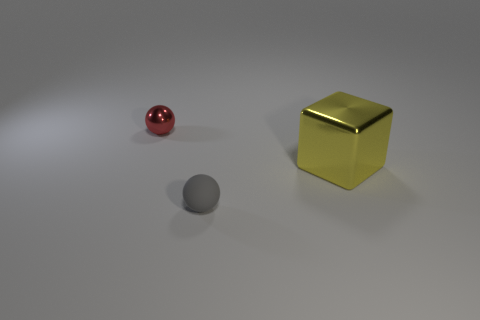Are there any other things that have the same size as the yellow metal cube?
Give a very brief answer. No. What material is the other small red object that is the same shape as the rubber object?
Provide a short and direct response. Metal. Is there any other thing that is the same material as the tiny gray sphere?
Your answer should be very brief. No. What number of other objects are the same shape as the tiny rubber object?
Your answer should be compact. 1. What shape is the big yellow object behind the small gray sphere?
Provide a succinct answer. Cube. What is the color of the large metal cube?
Offer a very short reply. Yellow. How many other objects are there of the same size as the gray thing?
Your response must be concise. 1. What material is the sphere that is on the left side of the gray rubber object that is to the left of the big metallic cube made of?
Your answer should be compact. Metal. Does the yellow cube have the same size as the object behind the large yellow block?
Offer a very short reply. No. What number of small objects are either yellow matte things or rubber spheres?
Your response must be concise. 1. 